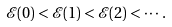Convert formula to latex. <formula><loc_0><loc_0><loc_500><loc_500>\mathcal { E } ( 0 ) < \mathcal { E } ( 1 ) < \mathcal { E } ( 2 ) < \cdots .</formula> 